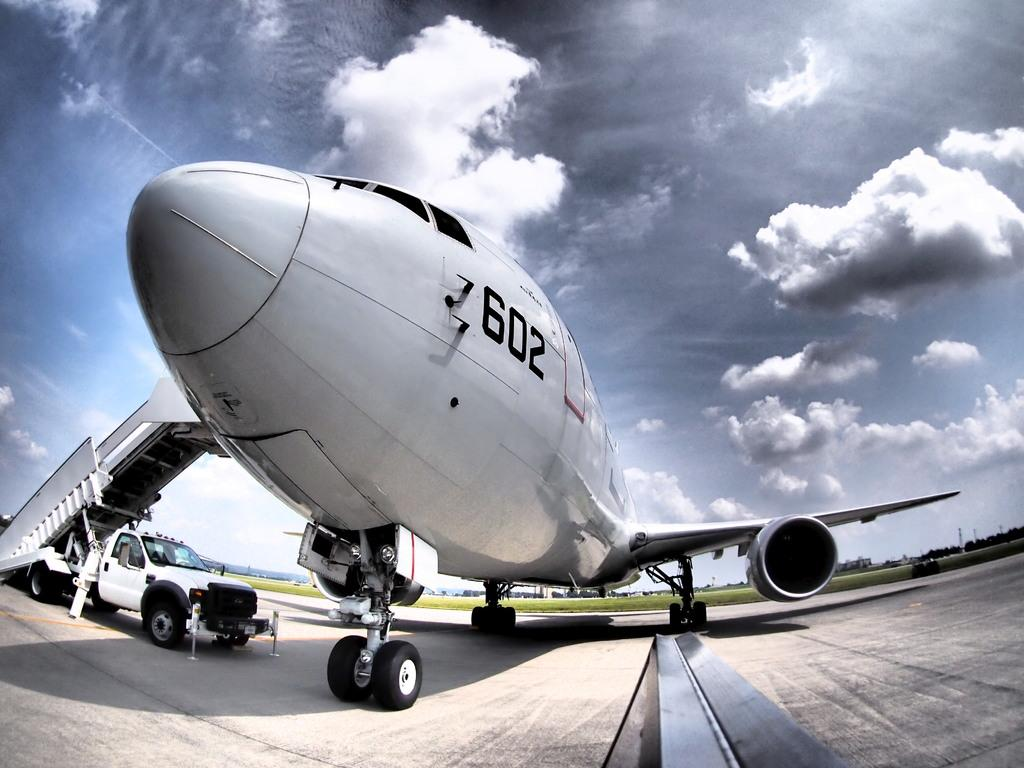<image>
Offer a succinct explanation of the picture presented. a 602 airplane is sitting with the stairs connected to it 